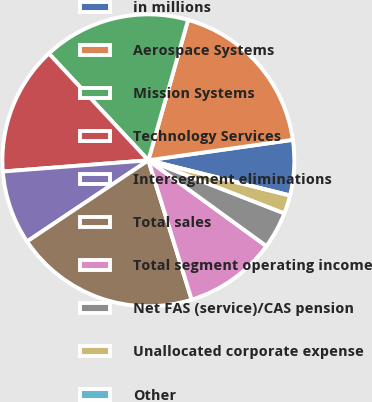<chart> <loc_0><loc_0><loc_500><loc_500><pie_chart><fcel>in millions<fcel>Aerospace Systems<fcel>Mission Systems<fcel>Technology Services<fcel>Intersegment eliminations<fcel>Total sales<fcel>Total segment operating income<fcel>Net FAS (service)/CAS pension<fcel>Unallocated corporate expense<fcel>Other<nl><fcel>6.12%<fcel>18.36%<fcel>16.32%<fcel>14.28%<fcel>8.16%<fcel>20.4%<fcel>10.2%<fcel>4.08%<fcel>2.04%<fcel>0.0%<nl></chart> 